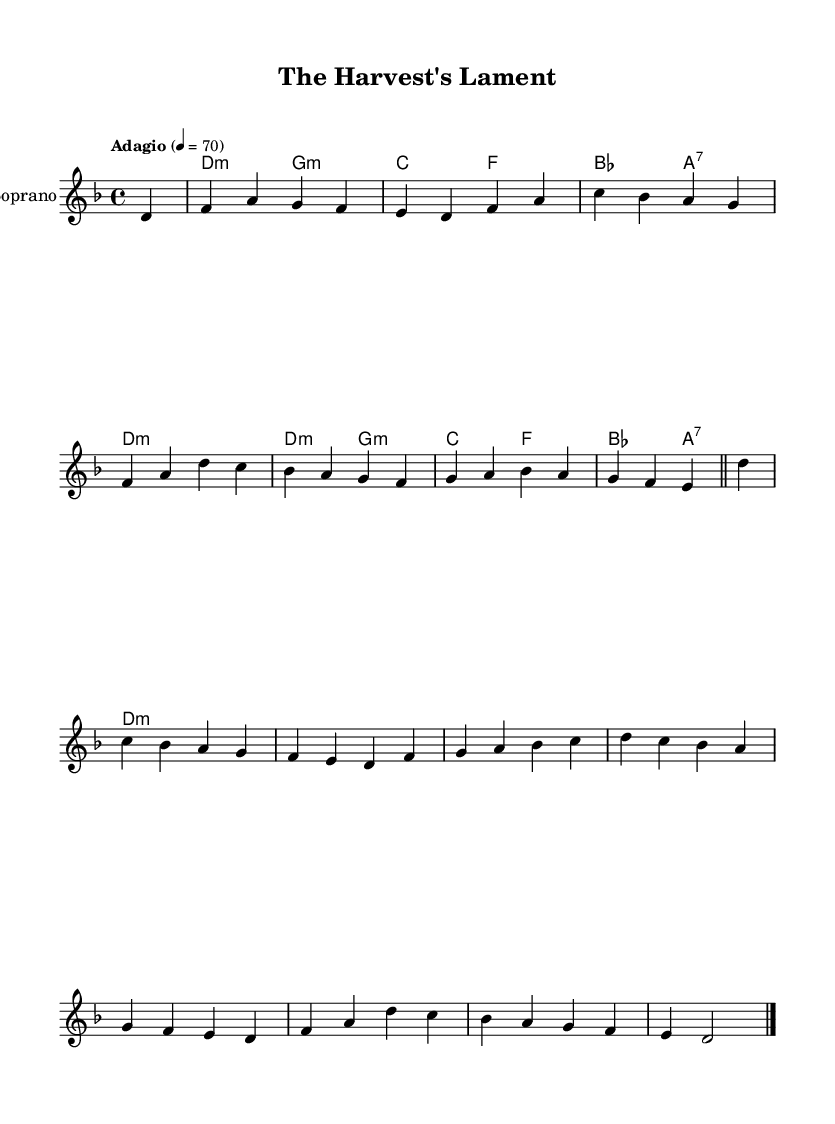What is the key signature of this music? The key signature is D minor, which has one flat (B♭). This can be determined by looking at the key signature at the beginning of the staff, which is indicated by the flat symbol beside the B line.
Answer: D minor What is the time signature of this music? The time signature is 4/4, which is indicated at the beginning of the score. It shows that there are four beats in each measure and the quarter note is the unit of beat.
Answer: 4/4 What is the tempo indicated in the music? The tempo is marked "Adagio" with a metronome marking of 4 = 70. "Adagio" indicates a slow tempo, and the number specifies that there are 70 beats per minute.
Answer: Adagio, 4 = 70 How many voices are in this opera piece? The piece features one voice, specifically a soprano, as indicated by the new staff labeled "Soprano". There is no indication of other vocal parts being included.
Answer: One voice What is the main theme expressed in the lyrics? The lyrics express a conflict between traditional farming methods and modern industrial agriculture, highlighted by the struggle against pesticides and chemical use that harm the land. This is evident from the words used in both the verse and the chorus of the lyrics.
Answer: Conflict between farming methods What chord progression is primarily used in the harmonies? The chord progression includes D minor, G minor, C major, F major, B♭ major, and A7, which repeats several times throughout the piece. This can be observed in the chord names listed under the staff in the harmonies section.
Answer: D minor, G minor, C major, F major, B♭ major, A7 What message is conveyed by the chorus lyrics? The chorus lyrics convey a plea for finding balance between tradition and modernity in agriculture and warns about the potential harm (poisoning) to life from current practices. This reflects a desire for harmony with nature rather than destruction.
Answer: Balance between tradition and modernity 